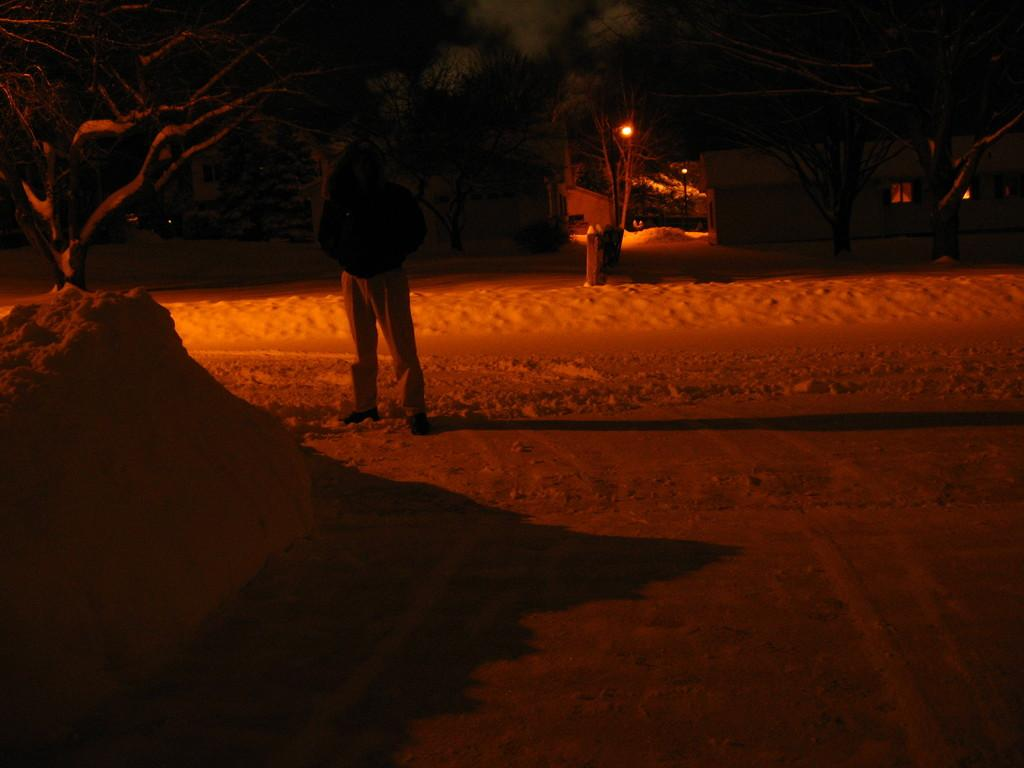What is the main subject of the image? There is a person standing in the image. What can be seen in the background of the image? There are trees and buildings with windows in the background of the image. What type of structures are present in the image? There are light poles in the image. What is on the list that the person is holding in the image? There is no list present in the image; the person is not holding anything. 